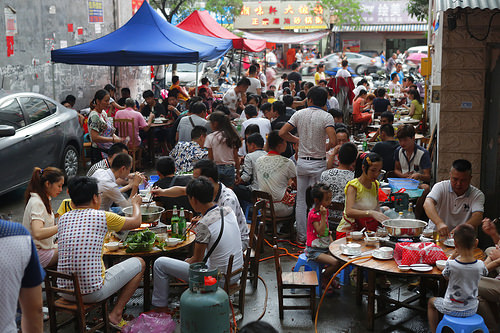<image>
Is there a man under the gazebo? No. The man is not positioned under the gazebo. The vertical relationship between these objects is different. Is there a man behind the boy? Yes. From this viewpoint, the man is positioned behind the boy, with the boy partially or fully occluding the man. 